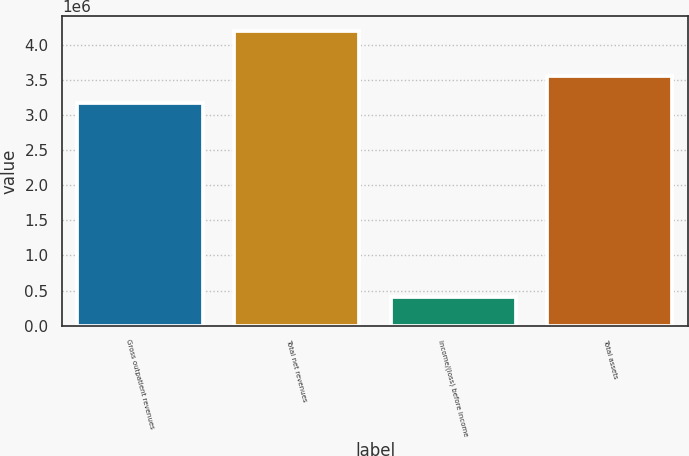Convert chart. <chart><loc_0><loc_0><loc_500><loc_500><bar_chart><fcel>Gross outpatient revenues<fcel>Total net revenues<fcel>Income/(loss) before income<fcel>Total assets<nl><fcel>3.16861e+06<fcel>4.1913e+06<fcel>412472<fcel>3.5465e+06<nl></chart> 